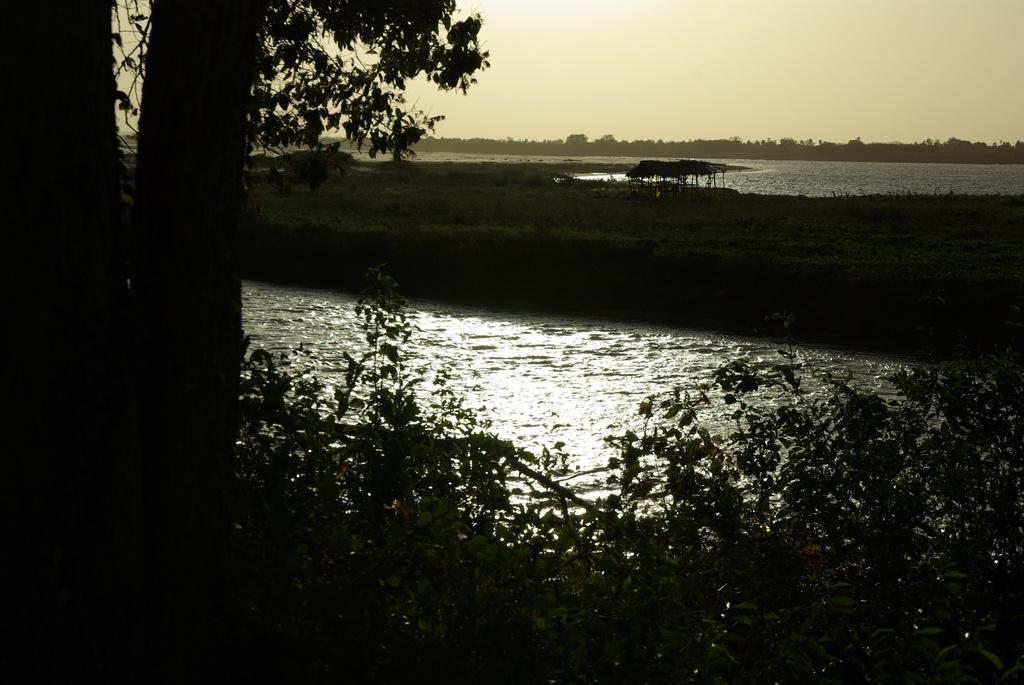Can you describe this image briefly? In this image there are trees, plants, water and a tent. At the top of the image there is sky. 